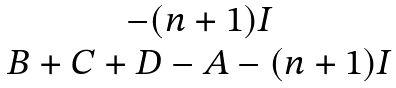<formula> <loc_0><loc_0><loc_500><loc_500>\begin{matrix} - ( n + 1 ) I \\ B + C + D - A - ( n + 1 ) I \end{matrix}</formula> 